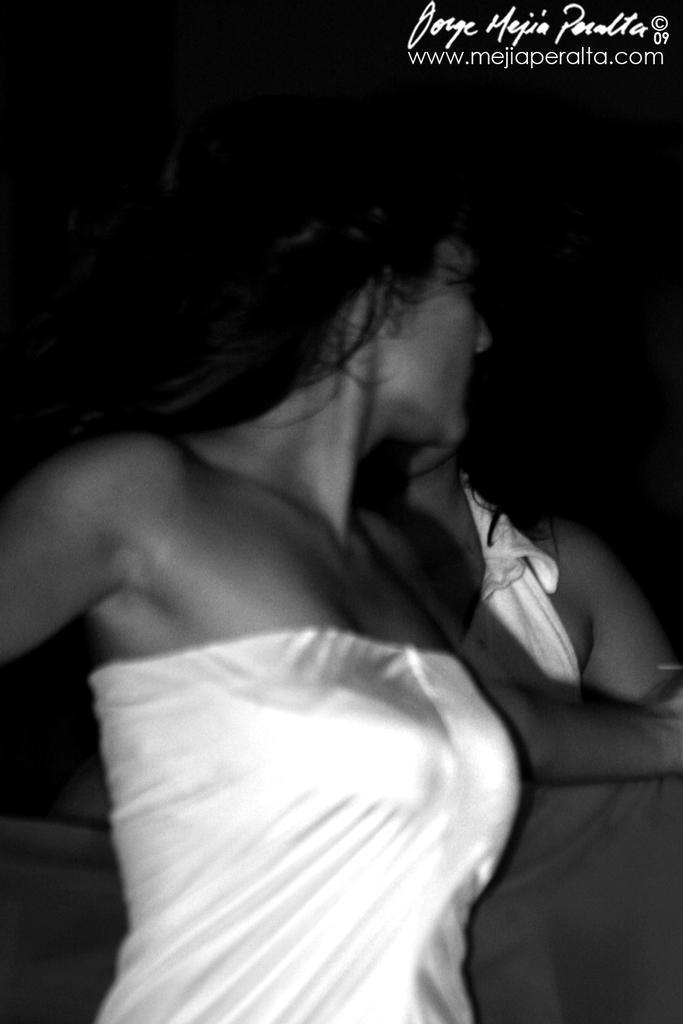Could you give a brief overview of what you see in this image? In the foreground we can see a woman and she is holding a bed sheet in her hands. In the background, we can see another person. 